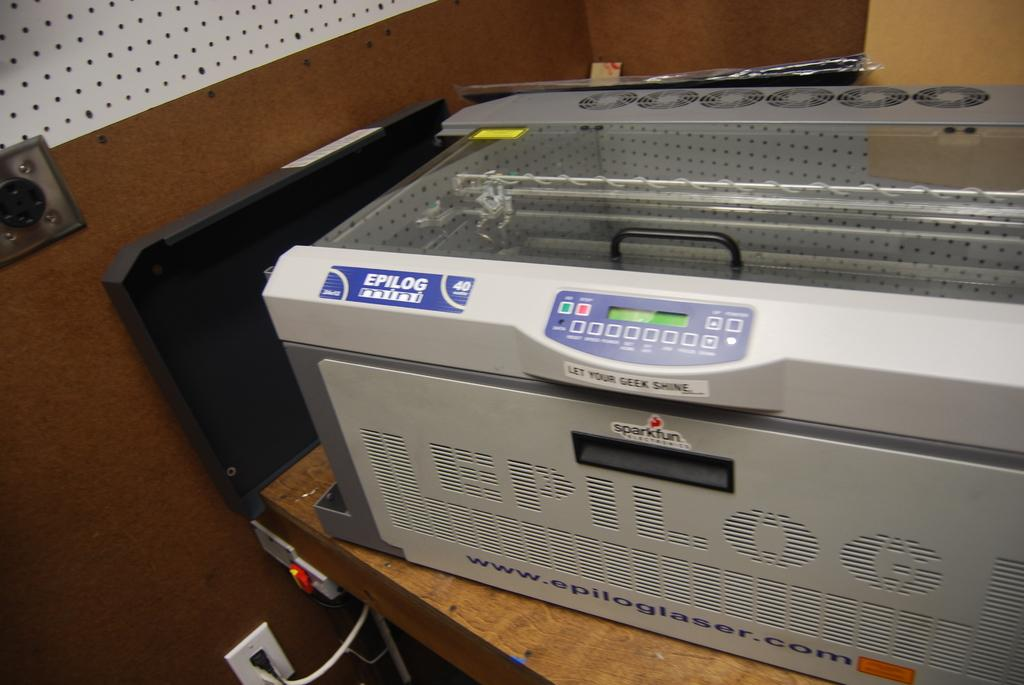<image>
Create a compact narrative representing the image presented. Gray printer with a blue label that says Epilog. 